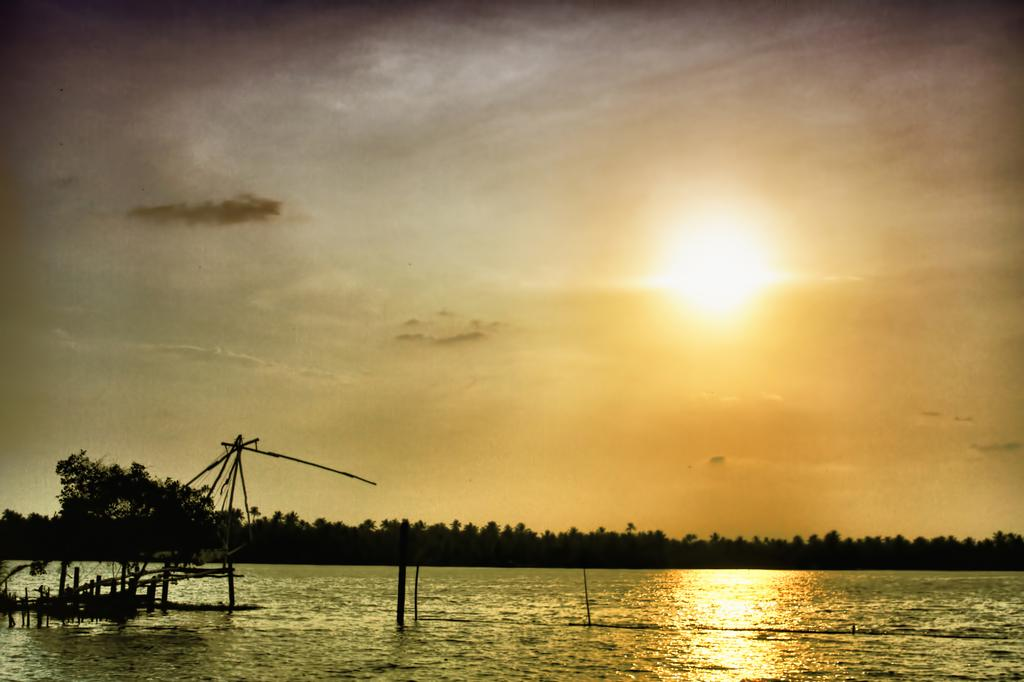What is visible in the image? Water is visible in the image. What can be seen in the background of the image? There are trees in the background of the image. What is visible in the sky in the image? The sky is visible in the image, and it contains clouds. What type of blade can be seen cutting through the trees in the image? There is no blade present in the image, and the trees are not being cut. 